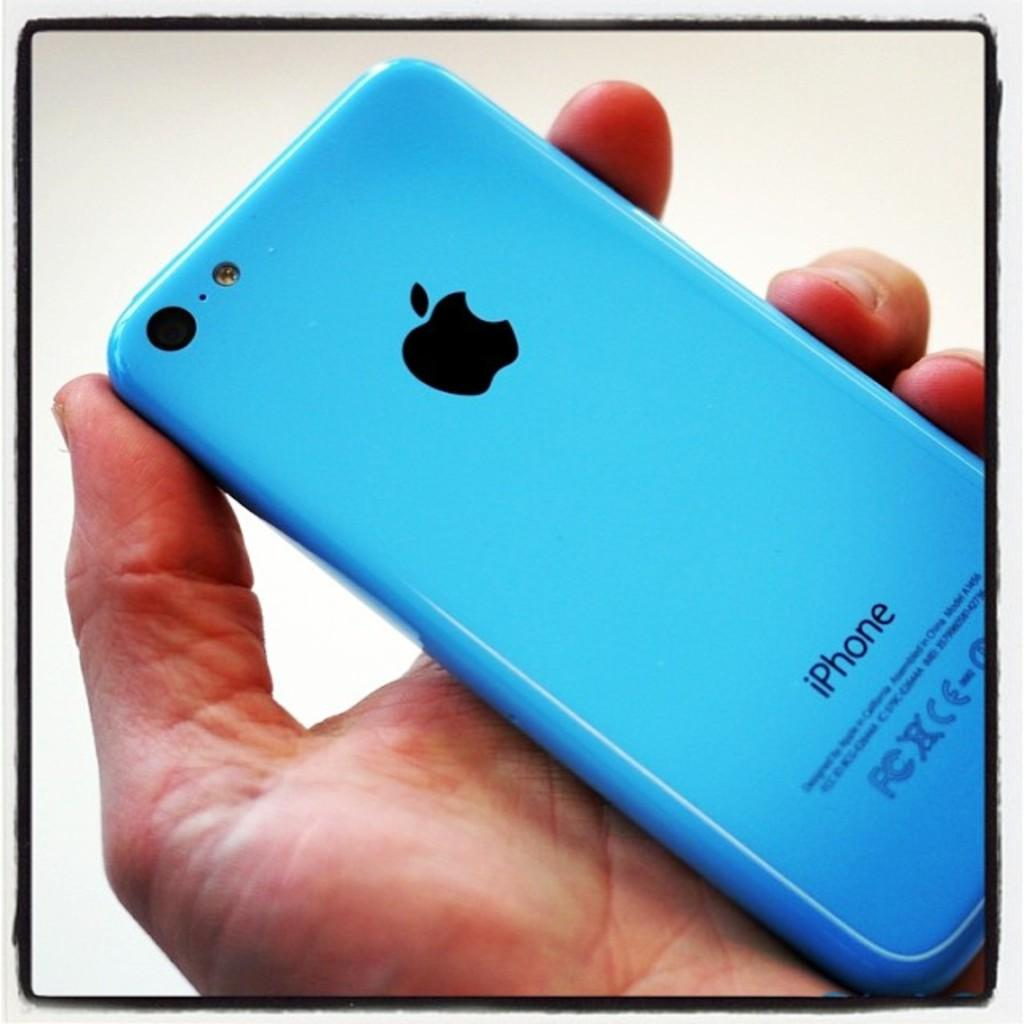Provide a one-sentence caption for the provided image. A person is holding an Apple iPhone with a blue colored case. 